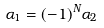Convert formula to latex. <formula><loc_0><loc_0><loc_500><loc_500>\alpha _ { 1 } = ( - 1 ) ^ { N } \alpha _ { 2 }</formula> 